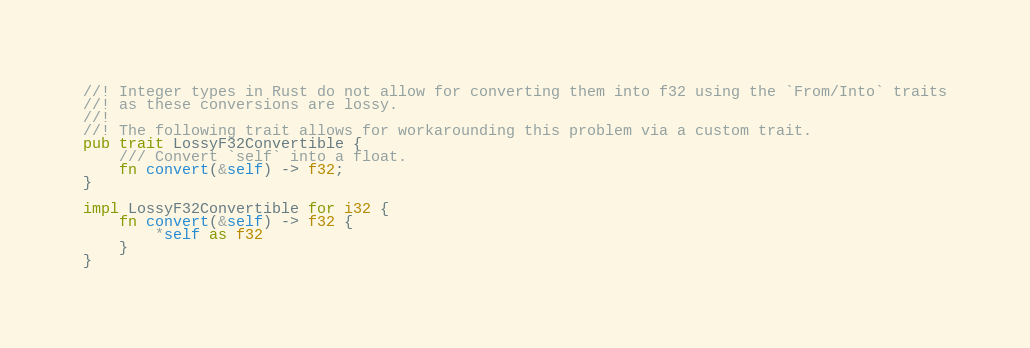<code> <loc_0><loc_0><loc_500><loc_500><_Rust_>//! Integer types in Rust do not allow for converting them into f32 using the `From/Into` traits
//! as these conversions are lossy.
//!
//! The following trait allows for workarounding this problem via a custom trait.
pub trait LossyF32Convertible {
    /// Convert `self` into a float.
    fn convert(&self) -> f32;
}

impl LossyF32Convertible for i32 {
    fn convert(&self) -> f32 {
        *self as f32
    }
}
</code> 